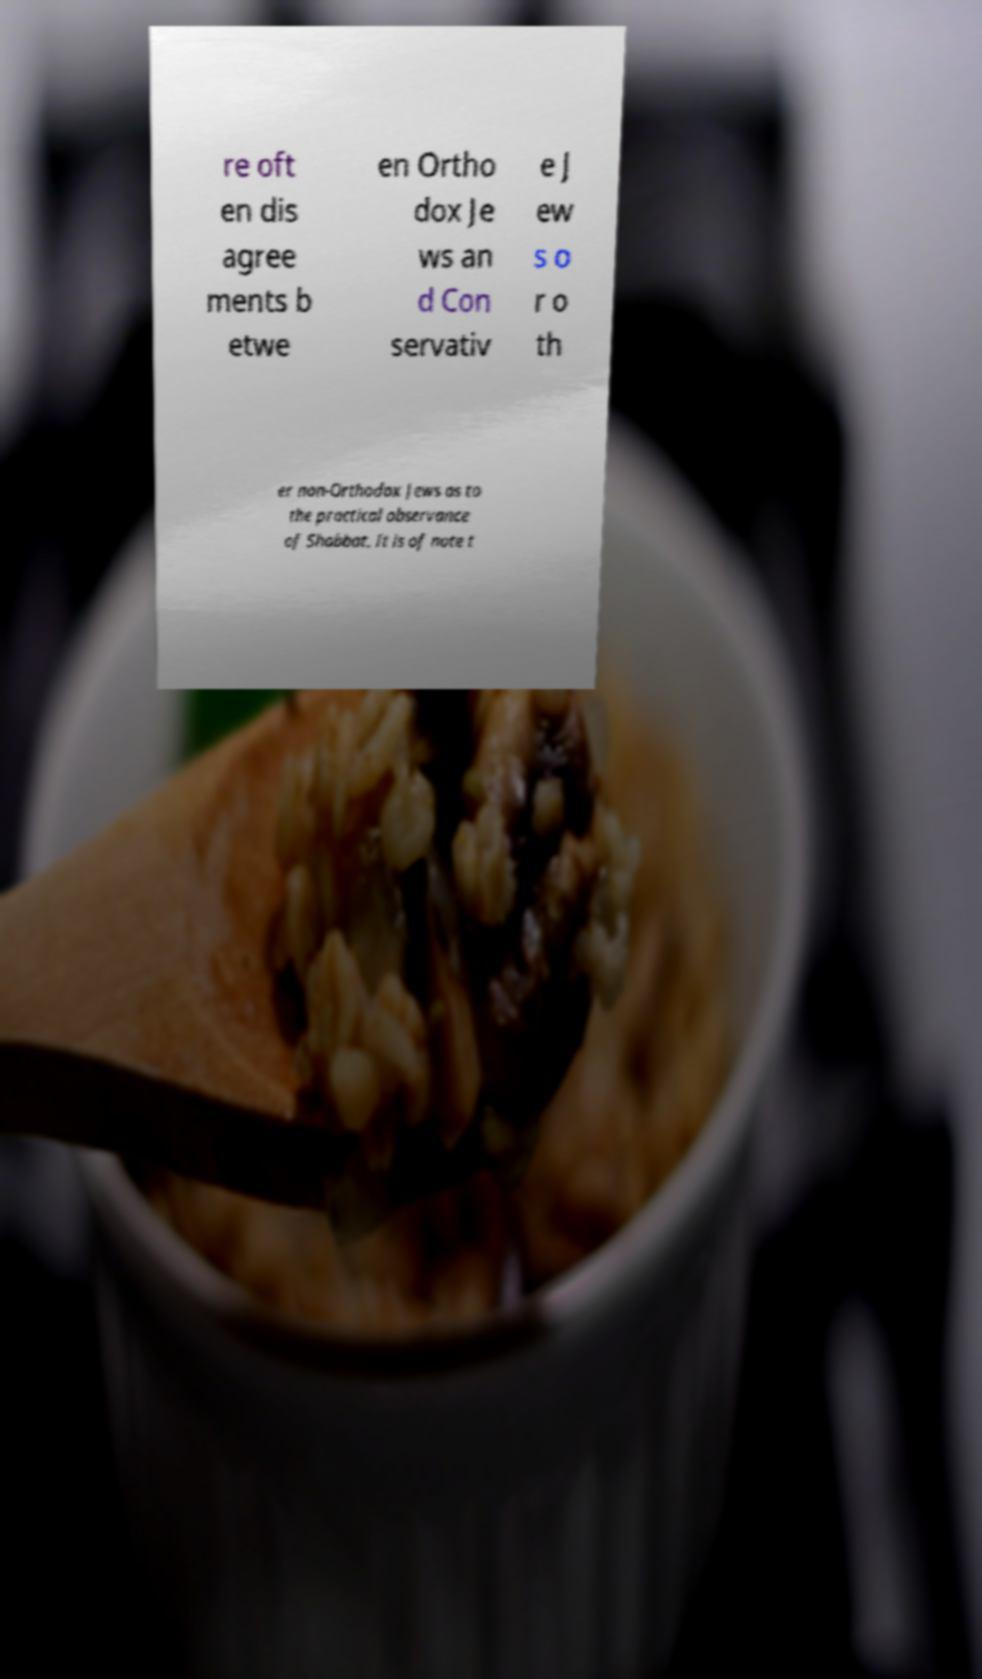I need the written content from this picture converted into text. Can you do that? re oft en dis agree ments b etwe en Ortho dox Je ws an d Con servativ e J ew s o r o th er non-Orthodox Jews as to the practical observance of Shabbat. It is of note t 